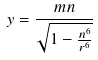Convert formula to latex. <formula><loc_0><loc_0><loc_500><loc_500>y = \frac { m n } { \sqrt { 1 - \frac { n ^ { 6 } } { r ^ { 6 } } } }</formula> 